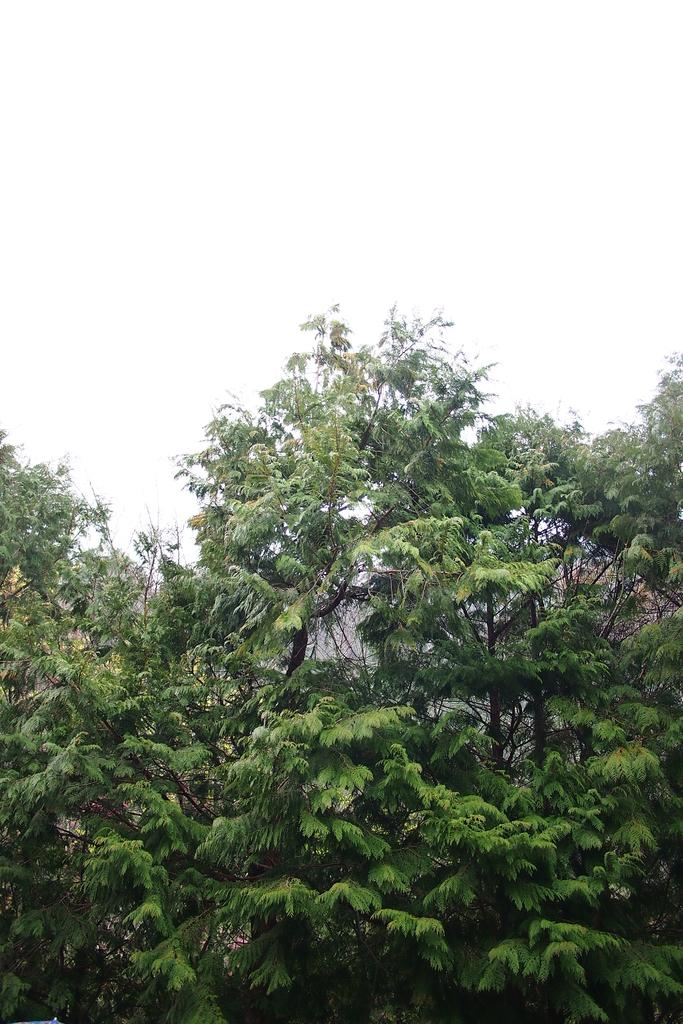What type of vegetation is present in the image? There are green trees in the image. What color is the background of the image? The background of the image is white. What type of pancake is being used for the operation in the image? There is no pancake or operation present in the image. What is the cause of the trees in the image? The cause of the trees in the image is not mentioned or visible; they are simply present in the image. 